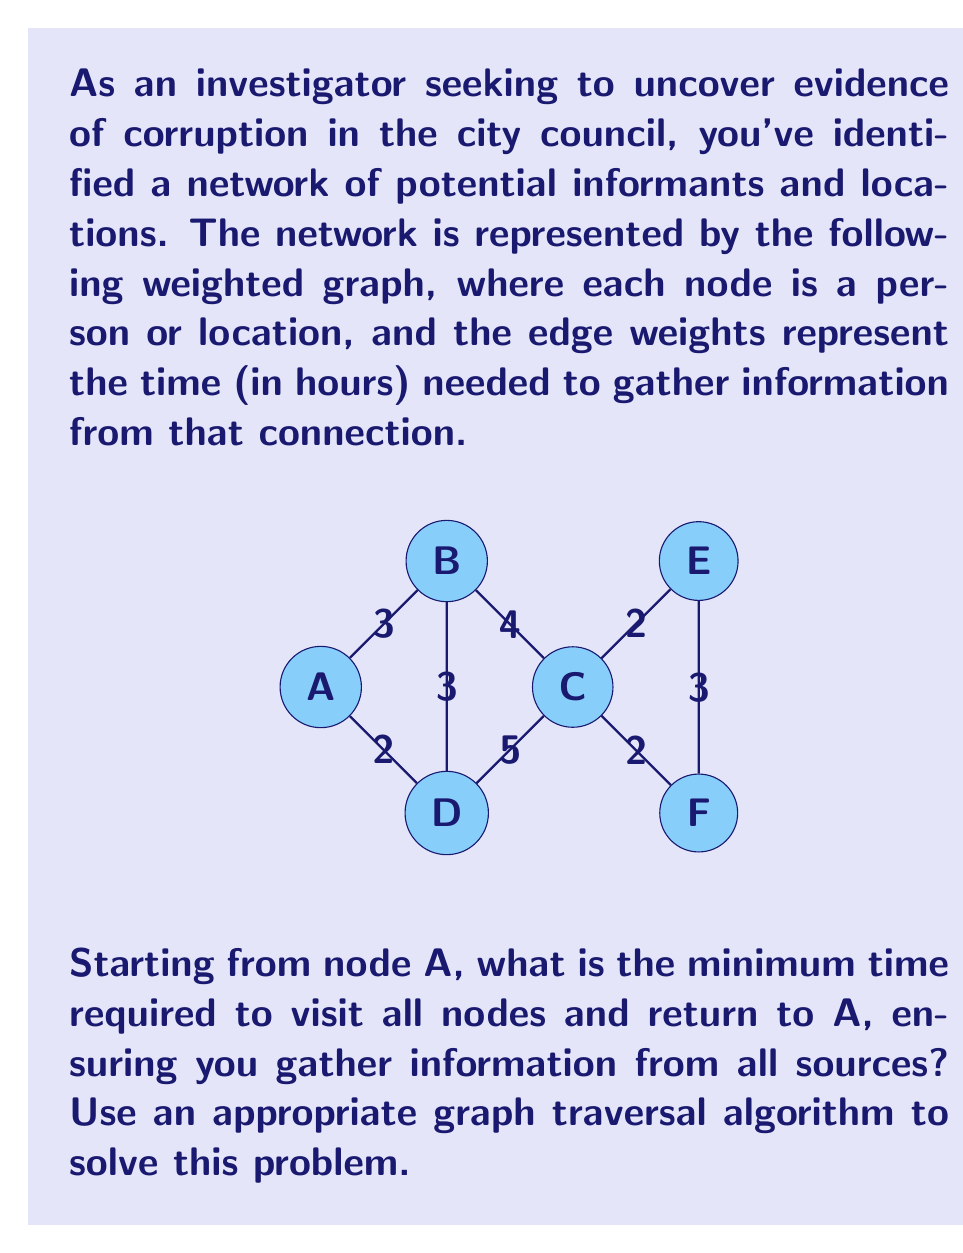Solve this math problem. To solve this problem, we need to find the minimum spanning tree (MST) of the graph and then perform a depth-first search (DFS) on the MST. This approach is known as the approximate solution to the Traveling Salesman Problem using MST.

Step 1: Find the Minimum Spanning Tree
We'll use Kruskal's algorithm to find the MST:

1. Sort all edges by weight:
   BD (3), CE (2), CF (2), AB (3), EF (3), BC (4), CD (5), AD (2)

2. Add edges to the MST, avoiding cycles:
   BD, CE, CF, AB, AD

The MST has a total weight of 12.

Step 2: Perform DFS on the MST
Starting from A, we'll perform a DFS:

A → B → D → C → E → F

Step 3: Calculate the total time
To visit all nodes and return to A, we need to traverse each edge of the MST twice (once in each direction) and add the time to return from the last node to A.

Total time = 2 * (sum of MST edges) + time to return to A
           = 2 * 12 + 2
           = 26 hours

Therefore, the minimum time required to visit all nodes and return to A is 26 hours.

This solution ensures that we gather information from all sources while minimizing the total time spent.
Answer: 26 hours 